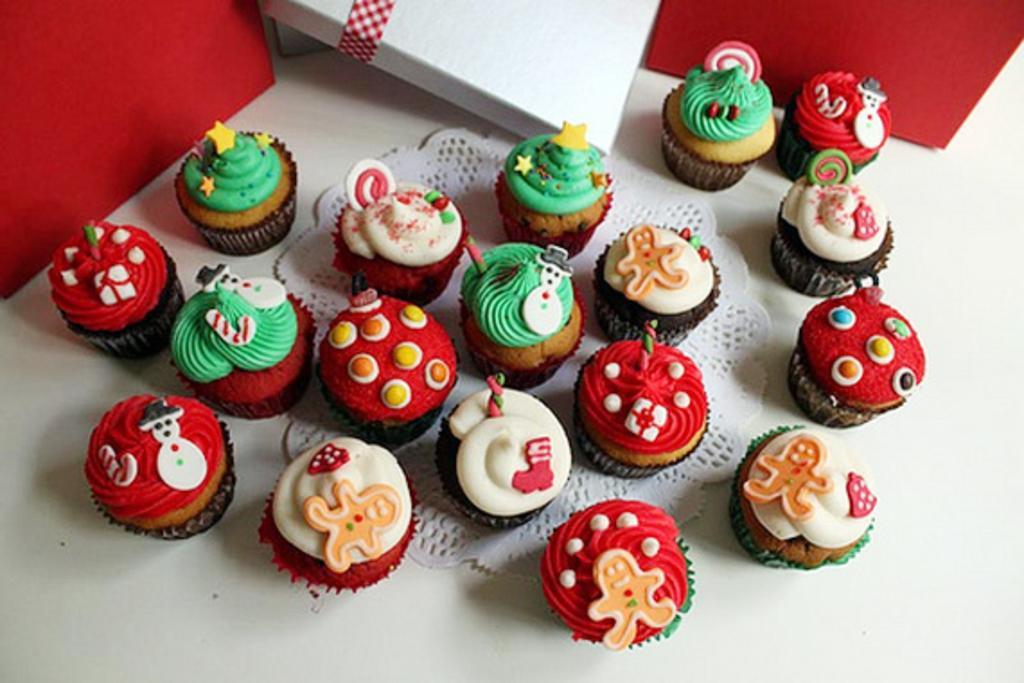Please provide a concise description of this image. In this picture we can see many cupcakes on the table, beside that we can see the cotton boxes. 